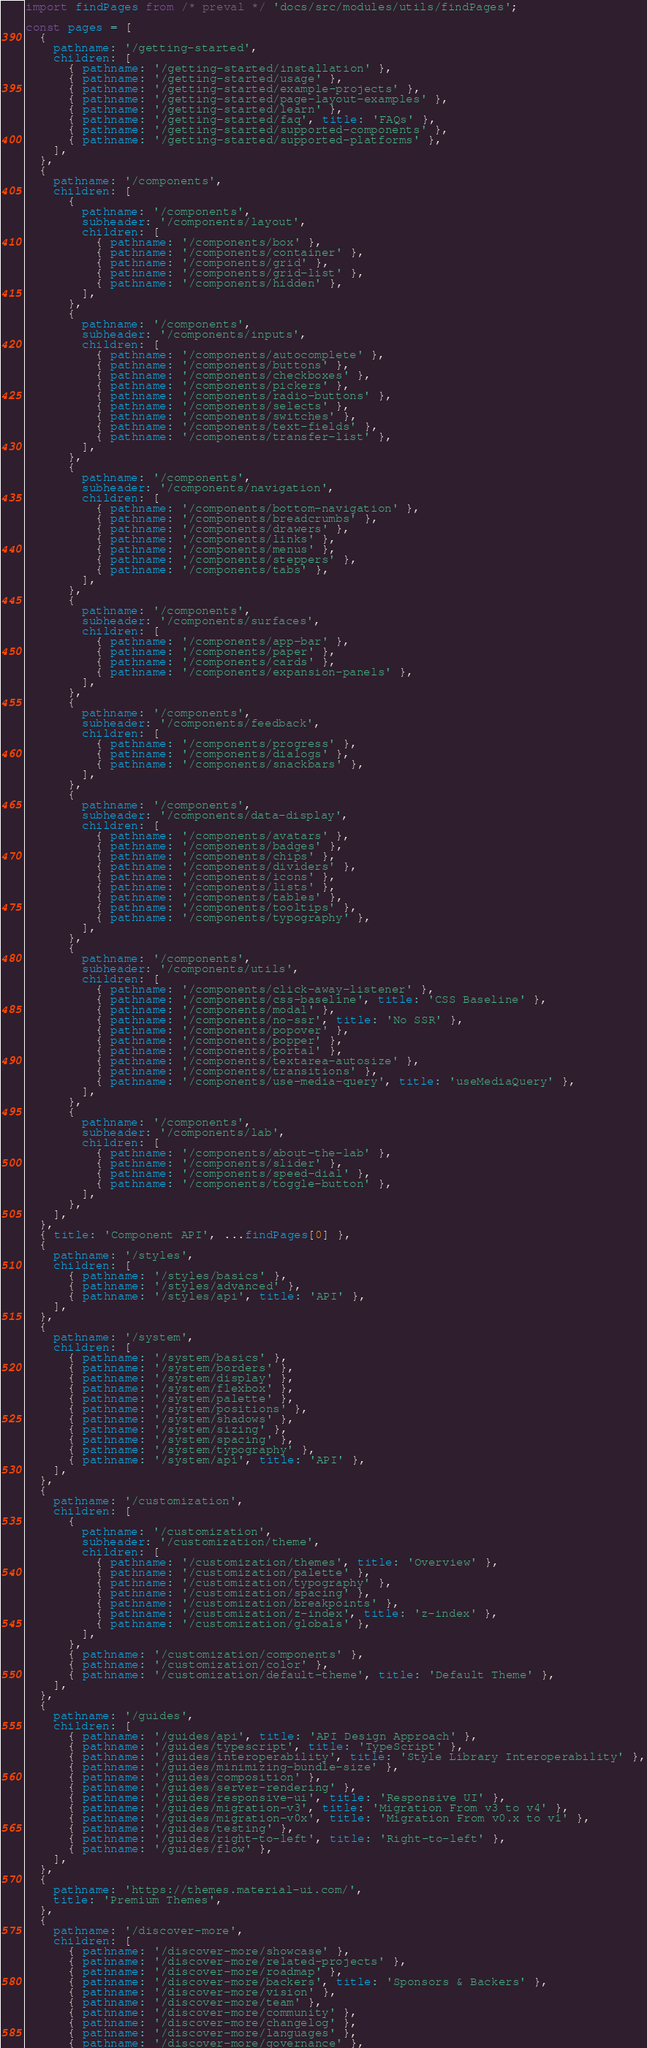Convert code to text. <code><loc_0><loc_0><loc_500><loc_500><_JavaScript_>import findPages from /* preval */ 'docs/src/modules/utils/findPages';

const pages = [
  {
    pathname: '/getting-started',
    children: [
      { pathname: '/getting-started/installation' },
      { pathname: '/getting-started/usage' },
      { pathname: '/getting-started/example-projects' },
      { pathname: '/getting-started/page-layout-examples' },
      { pathname: '/getting-started/learn' },
      { pathname: '/getting-started/faq', title: 'FAQs' },
      { pathname: '/getting-started/supported-components' },
      { pathname: '/getting-started/supported-platforms' },
    ],
  },
  {
    pathname: '/components',
    children: [
      {
        pathname: '/components',
        subheader: '/components/layout',
        children: [
          { pathname: '/components/box' },
          { pathname: '/components/container' },
          { pathname: '/components/grid' },
          { pathname: '/components/grid-list' },
          { pathname: '/components/hidden' },
        ],
      },
      {
        pathname: '/components',
        subheader: '/components/inputs',
        children: [
          { pathname: '/components/autocomplete' },
          { pathname: '/components/buttons' },
          { pathname: '/components/checkboxes' },
          { pathname: '/components/pickers' },
          { pathname: '/components/radio-buttons' },
          { pathname: '/components/selects' },
          { pathname: '/components/switches' },
          { pathname: '/components/text-fields' },
          { pathname: '/components/transfer-list' },
        ],
      },
      {
        pathname: '/components',
        subheader: '/components/navigation',
        children: [
          { pathname: '/components/bottom-navigation' },
          { pathname: '/components/breadcrumbs' },
          { pathname: '/components/drawers' },
          { pathname: '/components/links' },
          { pathname: '/components/menus' },
          { pathname: '/components/steppers' },
          { pathname: '/components/tabs' },
        ],
      },
      {
        pathname: '/components',
        subheader: '/components/surfaces',
        children: [
          { pathname: '/components/app-bar' },
          { pathname: '/components/paper' },
          { pathname: '/components/cards' },
          { pathname: '/components/expansion-panels' },
        ],
      },
      {
        pathname: '/components',
        subheader: '/components/feedback',
        children: [
          { pathname: '/components/progress' },
          { pathname: '/components/dialogs' },
          { pathname: '/components/snackbars' },
        ],
      },
      {
        pathname: '/components',
        subheader: '/components/data-display',
        children: [
          { pathname: '/components/avatars' },
          { pathname: '/components/badges' },
          { pathname: '/components/chips' },
          { pathname: '/components/dividers' },
          { pathname: '/components/icons' },
          { pathname: '/components/lists' },
          { pathname: '/components/tables' },
          { pathname: '/components/tooltips' },
          { pathname: '/components/typography' },
        ],
      },
      {
        pathname: '/components',
        subheader: '/components/utils',
        children: [
          { pathname: '/components/click-away-listener' },
          { pathname: '/components/css-baseline', title: 'CSS Baseline' },
          { pathname: '/components/modal' },
          { pathname: '/components/no-ssr', title: 'No SSR' },
          { pathname: '/components/popover' },
          { pathname: '/components/popper' },
          { pathname: '/components/portal' },
          { pathname: '/components/textarea-autosize' },
          { pathname: '/components/transitions' },
          { pathname: '/components/use-media-query', title: 'useMediaQuery' },
        ],
      },
      {
        pathname: '/components',
        subheader: '/components/lab',
        children: [
          { pathname: '/components/about-the-lab' },
          { pathname: '/components/slider' },
          { pathname: '/components/speed-dial' },
          { pathname: '/components/toggle-button' },
        ],
      },
    ],
  },
  { title: 'Component API', ...findPages[0] },
  {
    pathname: '/styles',
    children: [
      { pathname: '/styles/basics' },
      { pathname: '/styles/advanced' },
      { pathname: '/styles/api', title: 'API' },
    ],
  },
  {
    pathname: '/system',
    children: [
      { pathname: '/system/basics' },
      { pathname: '/system/borders' },
      { pathname: '/system/display' },
      { pathname: '/system/flexbox' },
      { pathname: '/system/palette' },
      { pathname: '/system/positions' },
      { pathname: '/system/shadows' },
      { pathname: '/system/sizing' },
      { pathname: '/system/spacing' },
      { pathname: '/system/typography' },
      { pathname: '/system/api', title: 'API' },
    ],
  },
  {
    pathname: '/customization',
    children: [
      {
        pathname: '/customization',
        subheader: '/customization/theme',
        children: [
          { pathname: '/customization/themes', title: 'Overview' },
          { pathname: '/customization/palette' },
          { pathname: '/customization/typography' },
          { pathname: '/customization/spacing' },
          { pathname: '/customization/breakpoints' },
          { pathname: '/customization/z-index', title: 'z-index' },
          { pathname: '/customization/globals' },
        ],
      },
      { pathname: '/customization/components' },
      { pathname: '/customization/color' },
      { pathname: '/customization/default-theme', title: 'Default Theme' },
    ],
  },
  {
    pathname: '/guides',
    children: [
      { pathname: '/guides/api', title: 'API Design Approach' },
      { pathname: '/guides/typescript', title: 'TypeScript' },
      { pathname: '/guides/interoperability', title: 'Style Library Interoperability' },
      { pathname: '/guides/minimizing-bundle-size' },
      { pathname: '/guides/composition' },
      { pathname: '/guides/server-rendering' },
      { pathname: '/guides/responsive-ui', title: 'Responsive UI' },
      { pathname: '/guides/migration-v3', title: 'Migration From v3 to v4' },
      { pathname: '/guides/migration-v0x', title: 'Migration From v0.x to v1' },
      { pathname: '/guides/testing' },
      { pathname: '/guides/right-to-left', title: 'Right-to-left' },
      { pathname: '/guides/flow' },
    ],
  },
  {
    pathname: 'https://themes.material-ui.com/',
    title: 'Premium Themes',
  },
  {
    pathname: '/discover-more',
    children: [
      { pathname: '/discover-more/showcase' },
      { pathname: '/discover-more/related-projects' },
      { pathname: '/discover-more/roadmap' },
      { pathname: '/discover-more/backers', title: 'Sponsors & Backers' },
      { pathname: '/discover-more/vision' },
      { pathname: '/discover-more/team' },
      { pathname: '/discover-more/community' },
      { pathname: '/discover-more/changelog' },
      { pathname: '/discover-more/languages' },
      { pathname: '/discover-more/governance' },</code> 